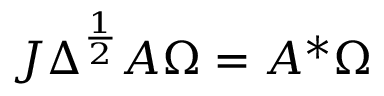<formula> <loc_0><loc_0><loc_500><loc_500>J \Delta ^ { \frac { 1 } { 2 } } A \Omega = A ^ { * } \Omega</formula> 